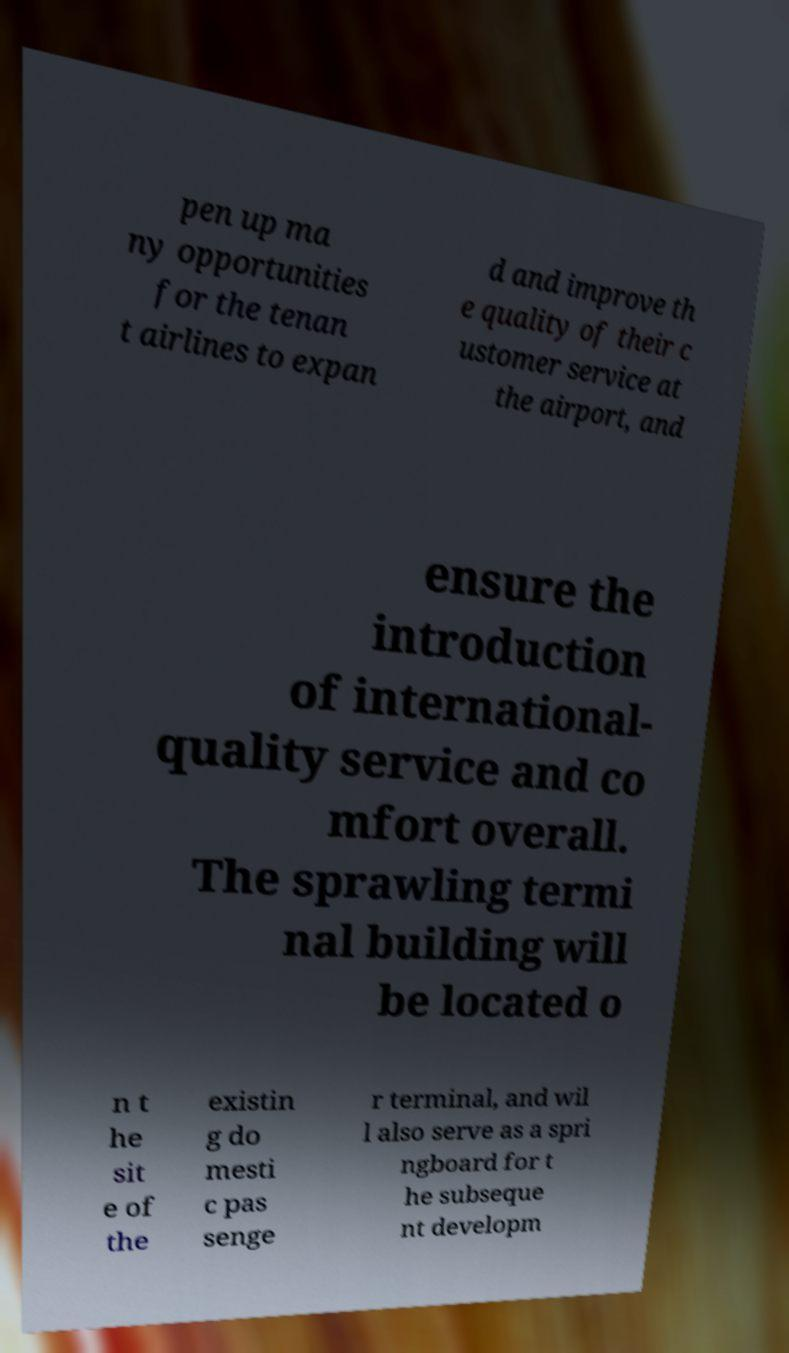For documentation purposes, I need the text within this image transcribed. Could you provide that? pen up ma ny opportunities for the tenan t airlines to expan d and improve th e quality of their c ustomer service at the airport, and ensure the introduction of international- quality service and co mfort overall. The sprawling termi nal building will be located o n t he sit e of the existin g do mesti c pas senge r terminal, and wil l also serve as a spri ngboard for t he subseque nt developm 